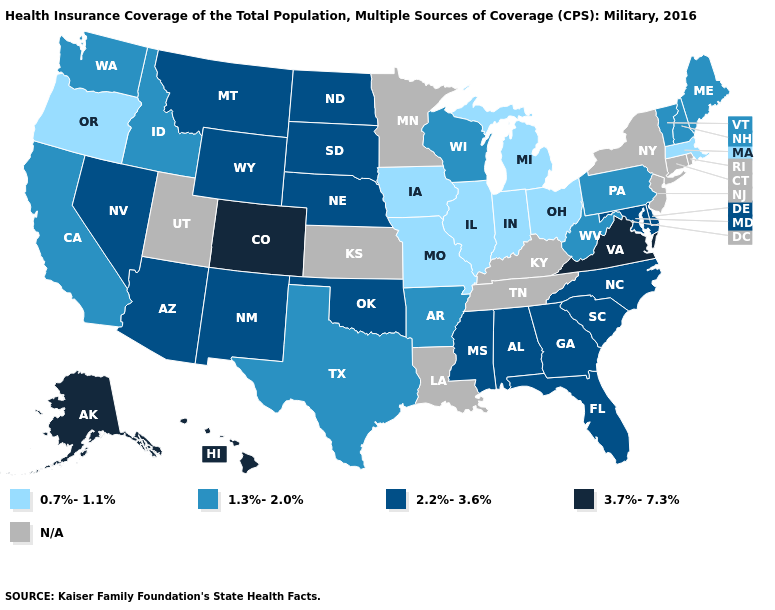Is the legend a continuous bar?
Keep it brief. No. Does the map have missing data?
Give a very brief answer. Yes. Among the states that border Oklahoma , which have the lowest value?
Keep it brief. Missouri. What is the value of Kentucky?
Give a very brief answer. N/A. What is the value of Minnesota?
Keep it brief. N/A. Among the states that border Wyoming , which have the highest value?
Give a very brief answer. Colorado. How many symbols are there in the legend?
Concise answer only. 5. Name the states that have a value in the range N/A?
Give a very brief answer. Connecticut, Kansas, Kentucky, Louisiana, Minnesota, New Jersey, New York, Rhode Island, Tennessee, Utah. Name the states that have a value in the range 2.2%-3.6%?
Keep it brief. Alabama, Arizona, Delaware, Florida, Georgia, Maryland, Mississippi, Montana, Nebraska, Nevada, New Mexico, North Carolina, North Dakota, Oklahoma, South Carolina, South Dakota, Wyoming. Which states hav the highest value in the South?
Short answer required. Virginia. Name the states that have a value in the range N/A?
Answer briefly. Connecticut, Kansas, Kentucky, Louisiana, Minnesota, New Jersey, New York, Rhode Island, Tennessee, Utah. What is the value of Nevada?
Give a very brief answer. 2.2%-3.6%. Does South Carolina have the lowest value in the USA?
Answer briefly. No. Does South Carolina have the lowest value in the South?
Be succinct. No. 